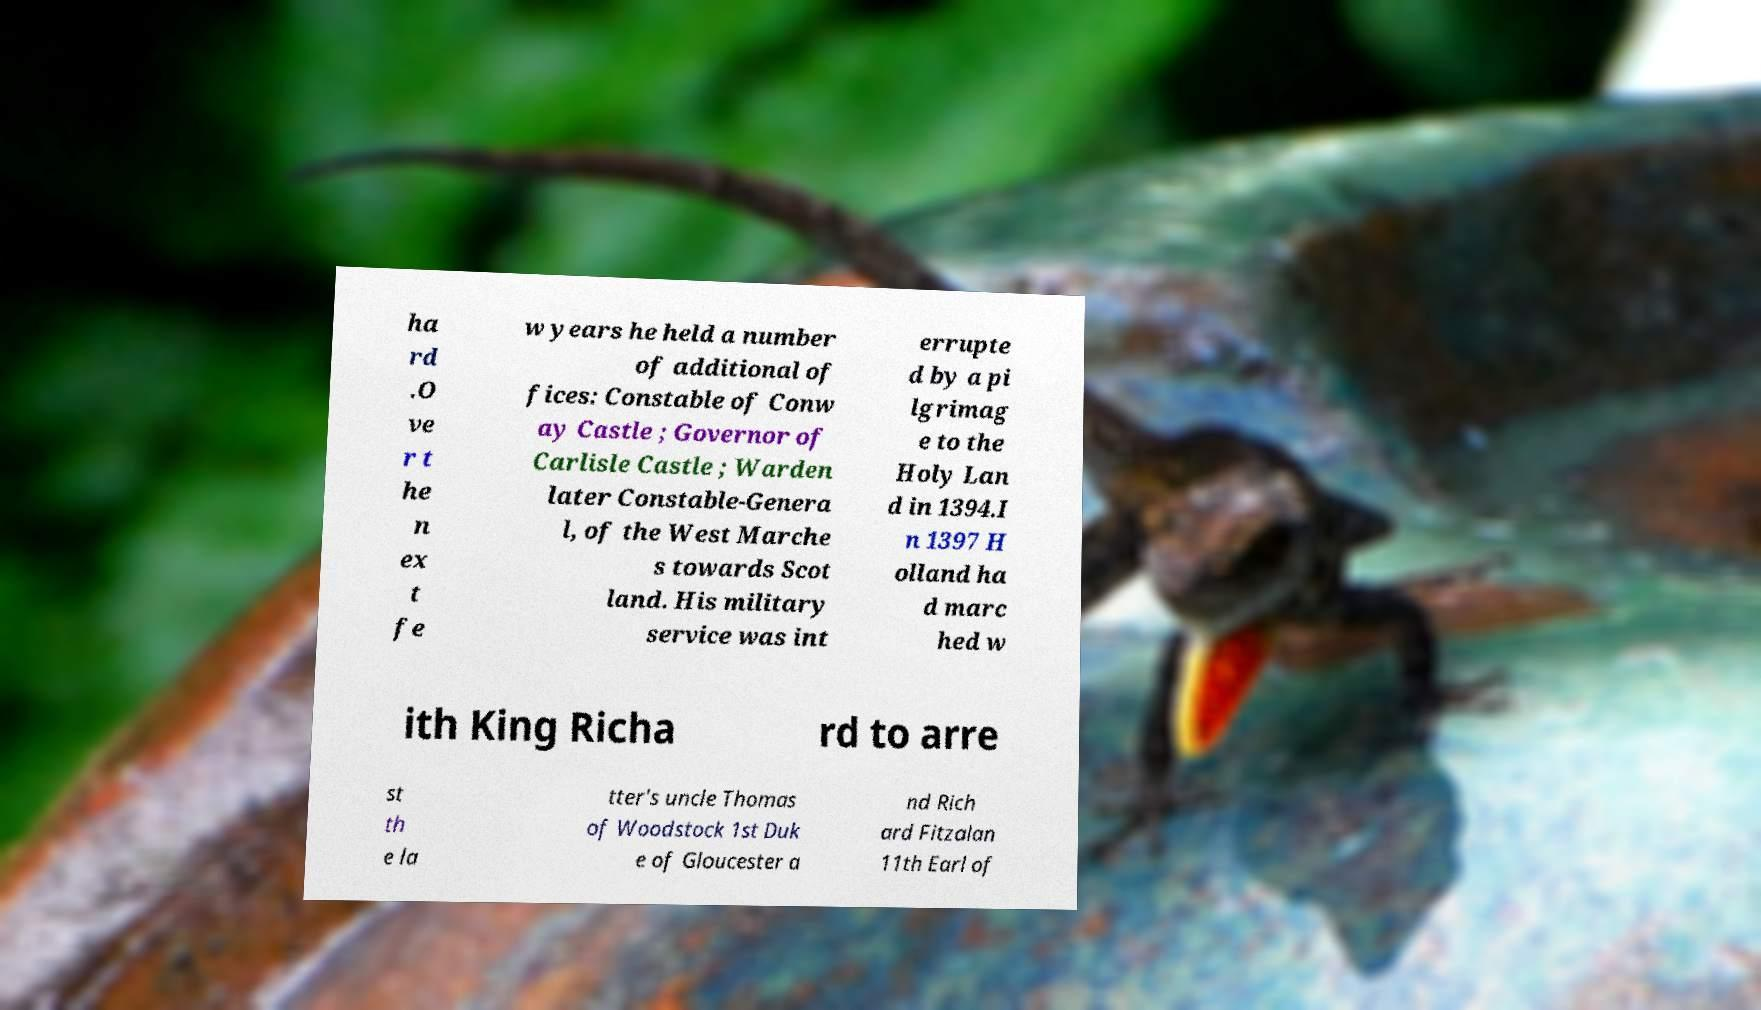Please identify and transcribe the text found in this image. ha rd .O ve r t he n ex t fe w years he held a number of additional of fices: Constable of Conw ay Castle ; Governor of Carlisle Castle ; Warden later Constable-Genera l, of the West Marche s towards Scot land. His military service was int errupte d by a pi lgrimag e to the Holy Lan d in 1394.I n 1397 H olland ha d marc hed w ith King Richa rd to arre st th e la tter's uncle Thomas of Woodstock 1st Duk e of Gloucester a nd Rich ard Fitzalan 11th Earl of 